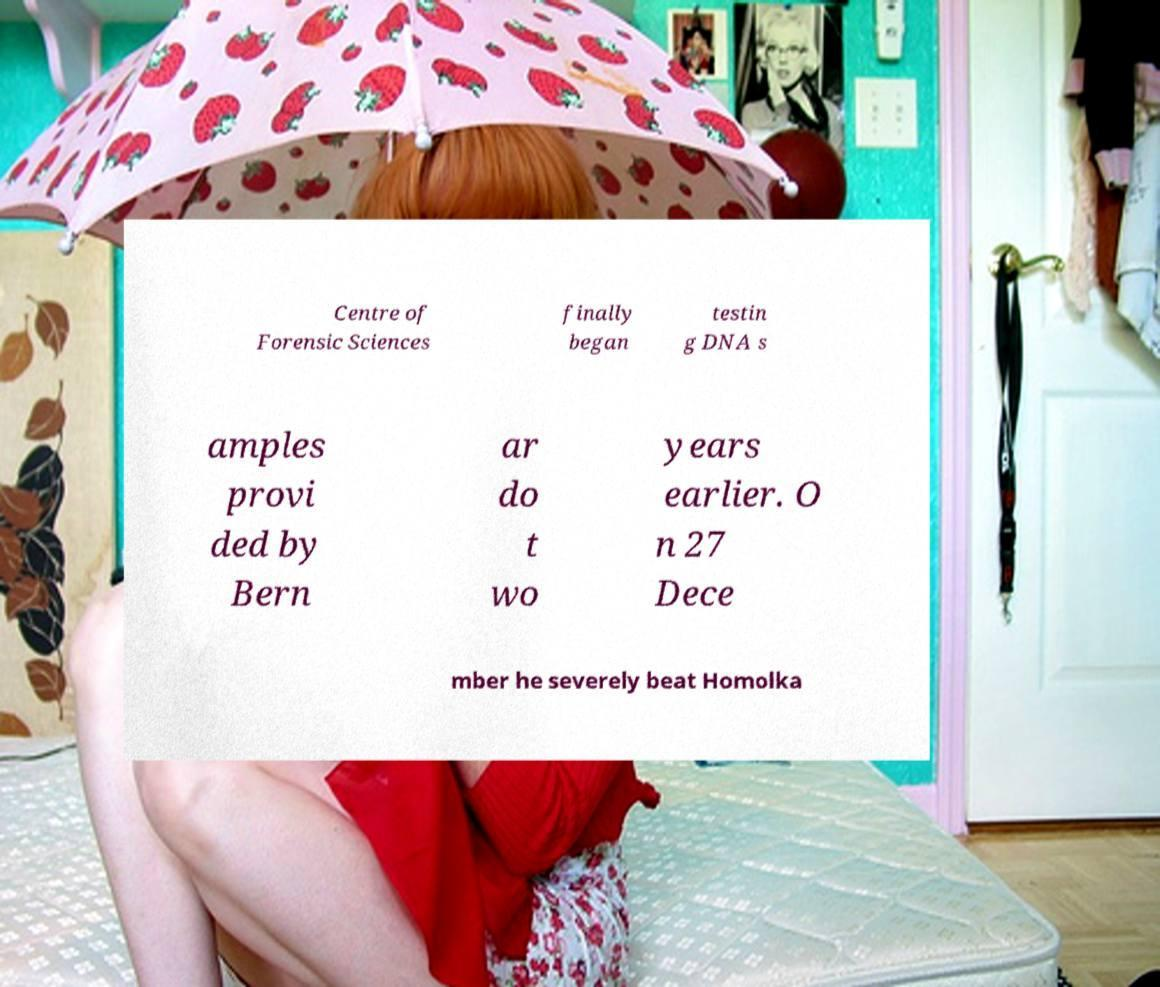Please read and relay the text visible in this image. What does it say? Centre of Forensic Sciences finally began testin g DNA s amples provi ded by Bern ar do t wo years earlier. O n 27 Dece mber he severely beat Homolka 